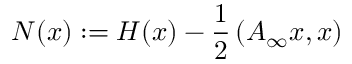Convert formula to latex. <formula><loc_0><loc_0><loc_500><loc_500>N ( x ) \colon = H ( x ) - \frac { 1 } { 2 } \left ( A _ { \infty } x , x \right )</formula> 